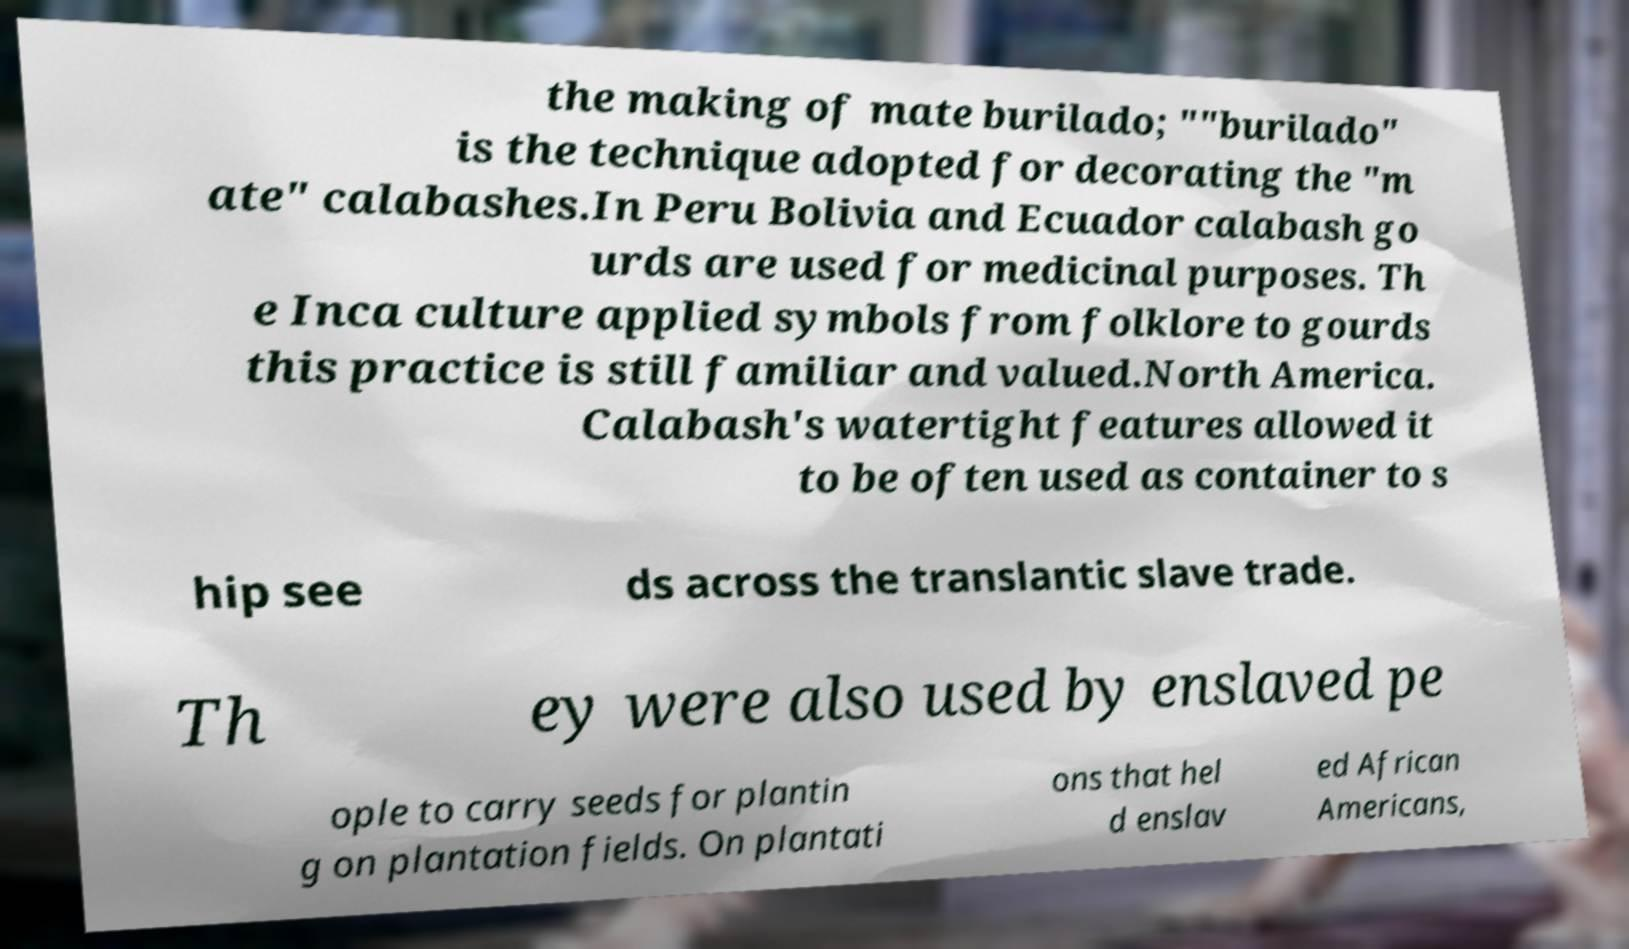For documentation purposes, I need the text within this image transcribed. Could you provide that? the making of mate burilado; ""burilado" is the technique adopted for decorating the "m ate" calabashes.In Peru Bolivia and Ecuador calabash go urds are used for medicinal purposes. Th e Inca culture applied symbols from folklore to gourds this practice is still familiar and valued.North America. Calabash's watertight features allowed it to be often used as container to s hip see ds across the translantic slave trade. Th ey were also used by enslaved pe ople to carry seeds for plantin g on plantation fields. On plantati ons that hel d enslav ed African Americans, 